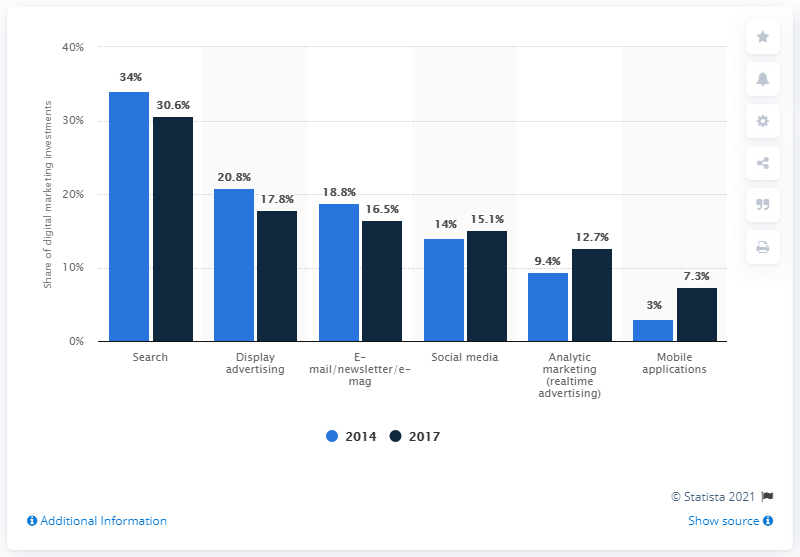Specify some key components in this picture. Retail managers and marketing directors anticipated a 17.8% decrease in their budget for digital marketing in 2017, as compared to the previous year. A survey of retail managers and marketing directors in Germany in 2014 revealed the distribution of investments in different digital marketing channels. The average use of social media across all years is 14.55. The light blue bars indicate the year 2014. 